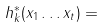<formula> <loc_0><loc_0><loc_500><loc_500>h ^ { * } _ { k } ( x _ { 1 } \dots x _ { t } ) =</formula> 